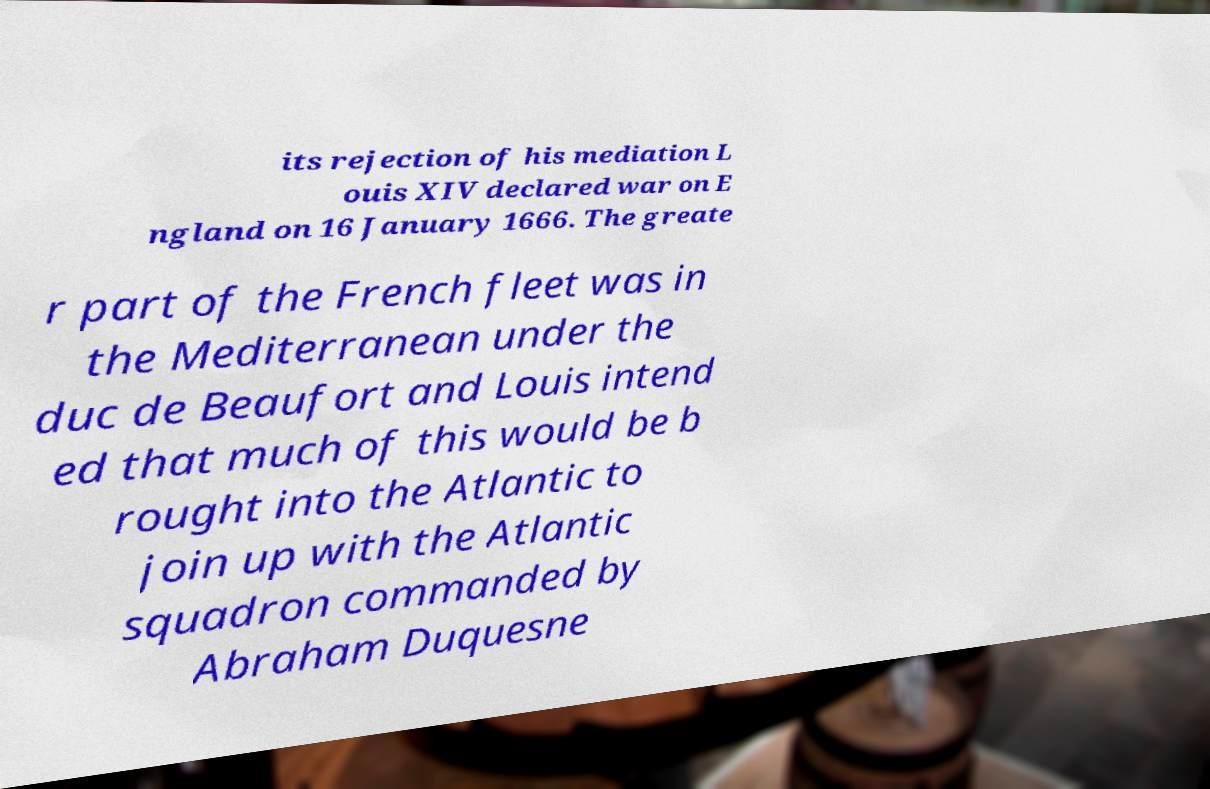What messages or text are displayed in this image? I need them in a readable, typed format. its rejection of his mediation L ouis XIV declared war on E ngland on 16 January 1666. The greate r part of the French fleet was in the Mediterranean under the duc de Beaufort and Louis intend ed that much of this would be b rought into the Atlantic to join up with the Atlantic squadron commanded by Abraham Duquesne 